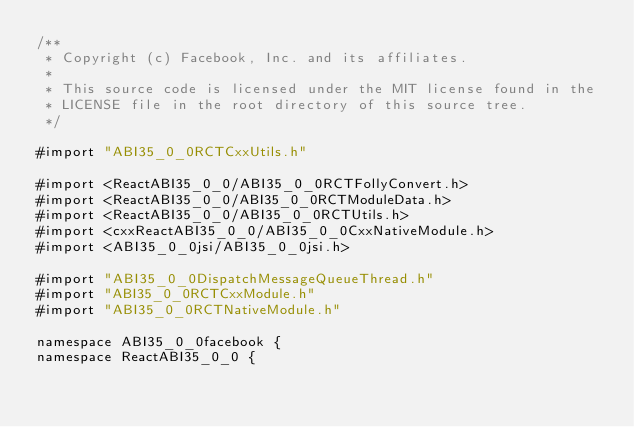<code> <loc_0><loc_0><loc_500><loc_500><_ObjectiveC_>/**
 * Copyright (c) Facebook, Inc. and its affiliates.
 *
 * This source code is licensed under the MIT license found in the
 * LICENSE file in the root directory of this source tree.
 */

#import "ABI35_0_0RCTCxxUtils.h"

#import <ReactABI35_0_0/ABI35_0_0RCTFollyConvert.h>
#import <ReactABI35_0_0/ABI35_0_0RCTModuleData.h>
#import <ReactABI35_0_0/ABI35_0_0RCTUtils.h>
#import <cxxReactABI35_0_0/ABI35_0_0CxxNativeModule.h>
#import <ABI35_0_0jsi/ABI35_0_0jsi.h>

#import "ABI35_0_0DispatchMessageQueueThread.h"
#import "ABI35_0_0RCTCxxModule.h"
#import "ABI35_0_0RCTNativeModule.h"

namespace ABI35_0_0facebook {
namespace ReactABI35_0_0 {
</code> 